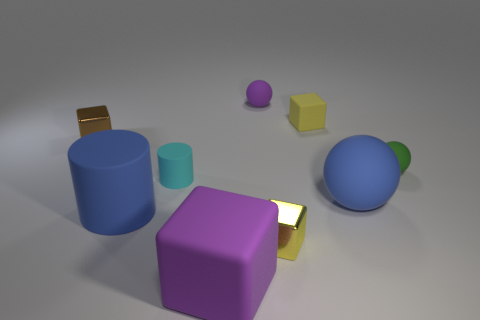Is the number of large blue cylinders that are in front of the tiny cyan matte cylinder less than the number of small objects that are behind the brown cube? After carefully analyzing the image, it appears that there is one large blue cylinder in front of the tiny cyan matte cylinder. As for the small objects behind the brown cube, there are two in total—a small purple sphere and a small yellow cube. Therefore, the number of large blue cylinders in front of the tiny cyan matte cylinder is indeed less than the number of small objects behind the brown cube, which is two. 